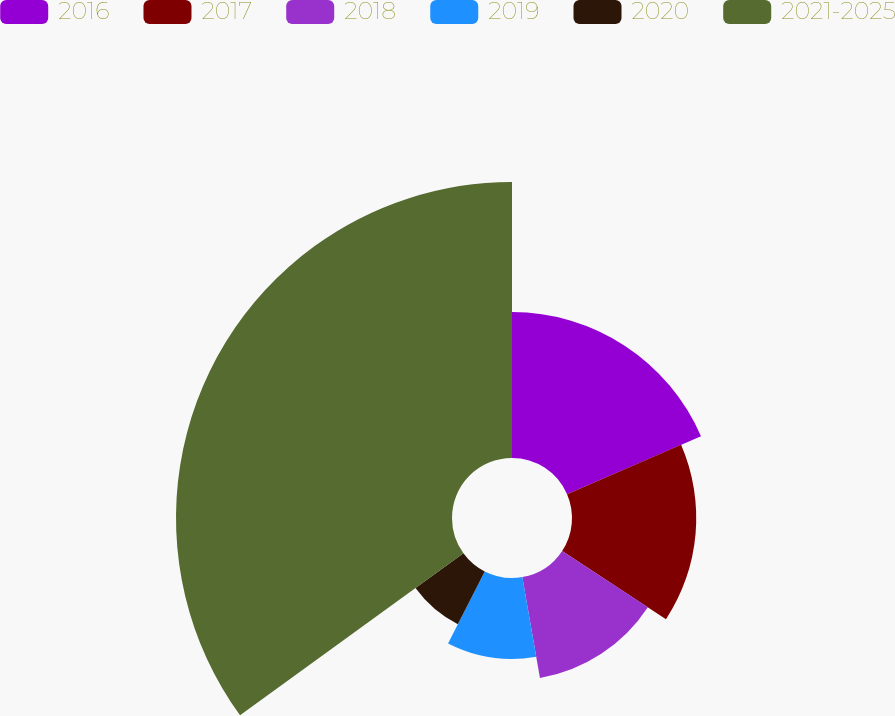<chart> <loc_0><loc_0><loc_500><loc_500><pie_chart><fcel>2016<fcel>2017<fcel>2018<fcel>2019<fcel>2020<fcel>2021-2025<nl><fcel>18.5%<fcel>15.75%<fcel>13.0%<fcel>10.25%<fcel>7.51%<fcel>34.99%<nl></chart> 